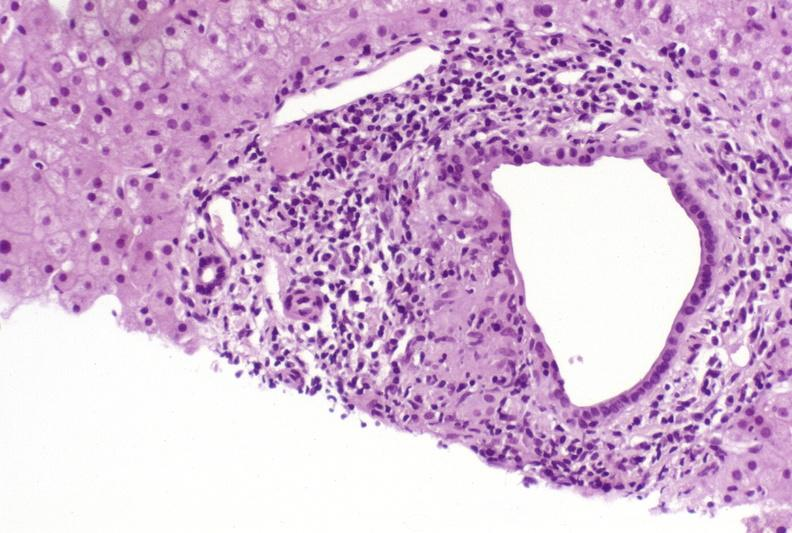s plasma cell present?
Answer the question using a single word or phrase. No 